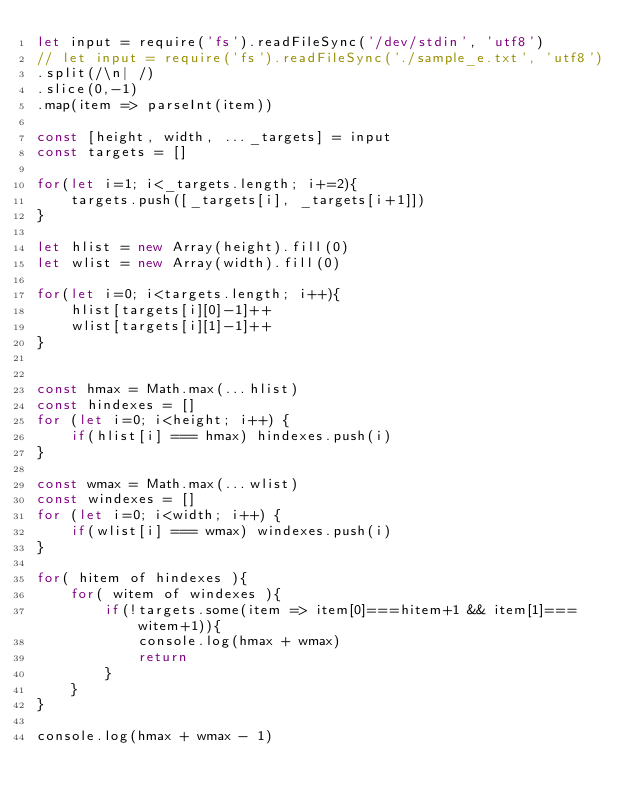<code> <loc_0><loc_0><loc_500><loc_500><_JavaScript_>let input = require('fs').readFileSync('/dev/stdin', 'utf8')
// let input = require('fs').readFileSync('./sample_e.txt', 'utf8')
.split(/\n| /)
.slice(0,-1)
.map(item => parseInt(item))

const [height, width, ..._targets] = input
const targets = []

for(let i=1; i<_targets.length; i+=2){
    targets.push([_targets[i], _targets[i+1]])
}

let hlist = new Array(height).fill(0)
let wlist = new Array(width).fill(0)

for(let i=0; i<targets.length; i++){
    hlist[targets[i][0]-1]++
    wlist[targets[i][1]-1]++
}


const hmax = Math.max(...hlist)
const hindexes = []
for (let i=0; i<height; i++) {
    if(hlist[i] === hmax) hindexes.push(i)
}

const wmax = Math.max(...wlist)
const windexes = []
for (let i=0; i<width; i++) {
    if(wlist[i] === wmax) windexes.push(i)
}

for( hitem of hindexes ){
    for( witem of windexes ){
        if(!targets.some(item => item[0]===hitem+1 && item[1]===witem+1)){
            console.log(hmax + wmax)
            return
        }
    }
}

console.log(hmax + wmax - 1)
</code> 